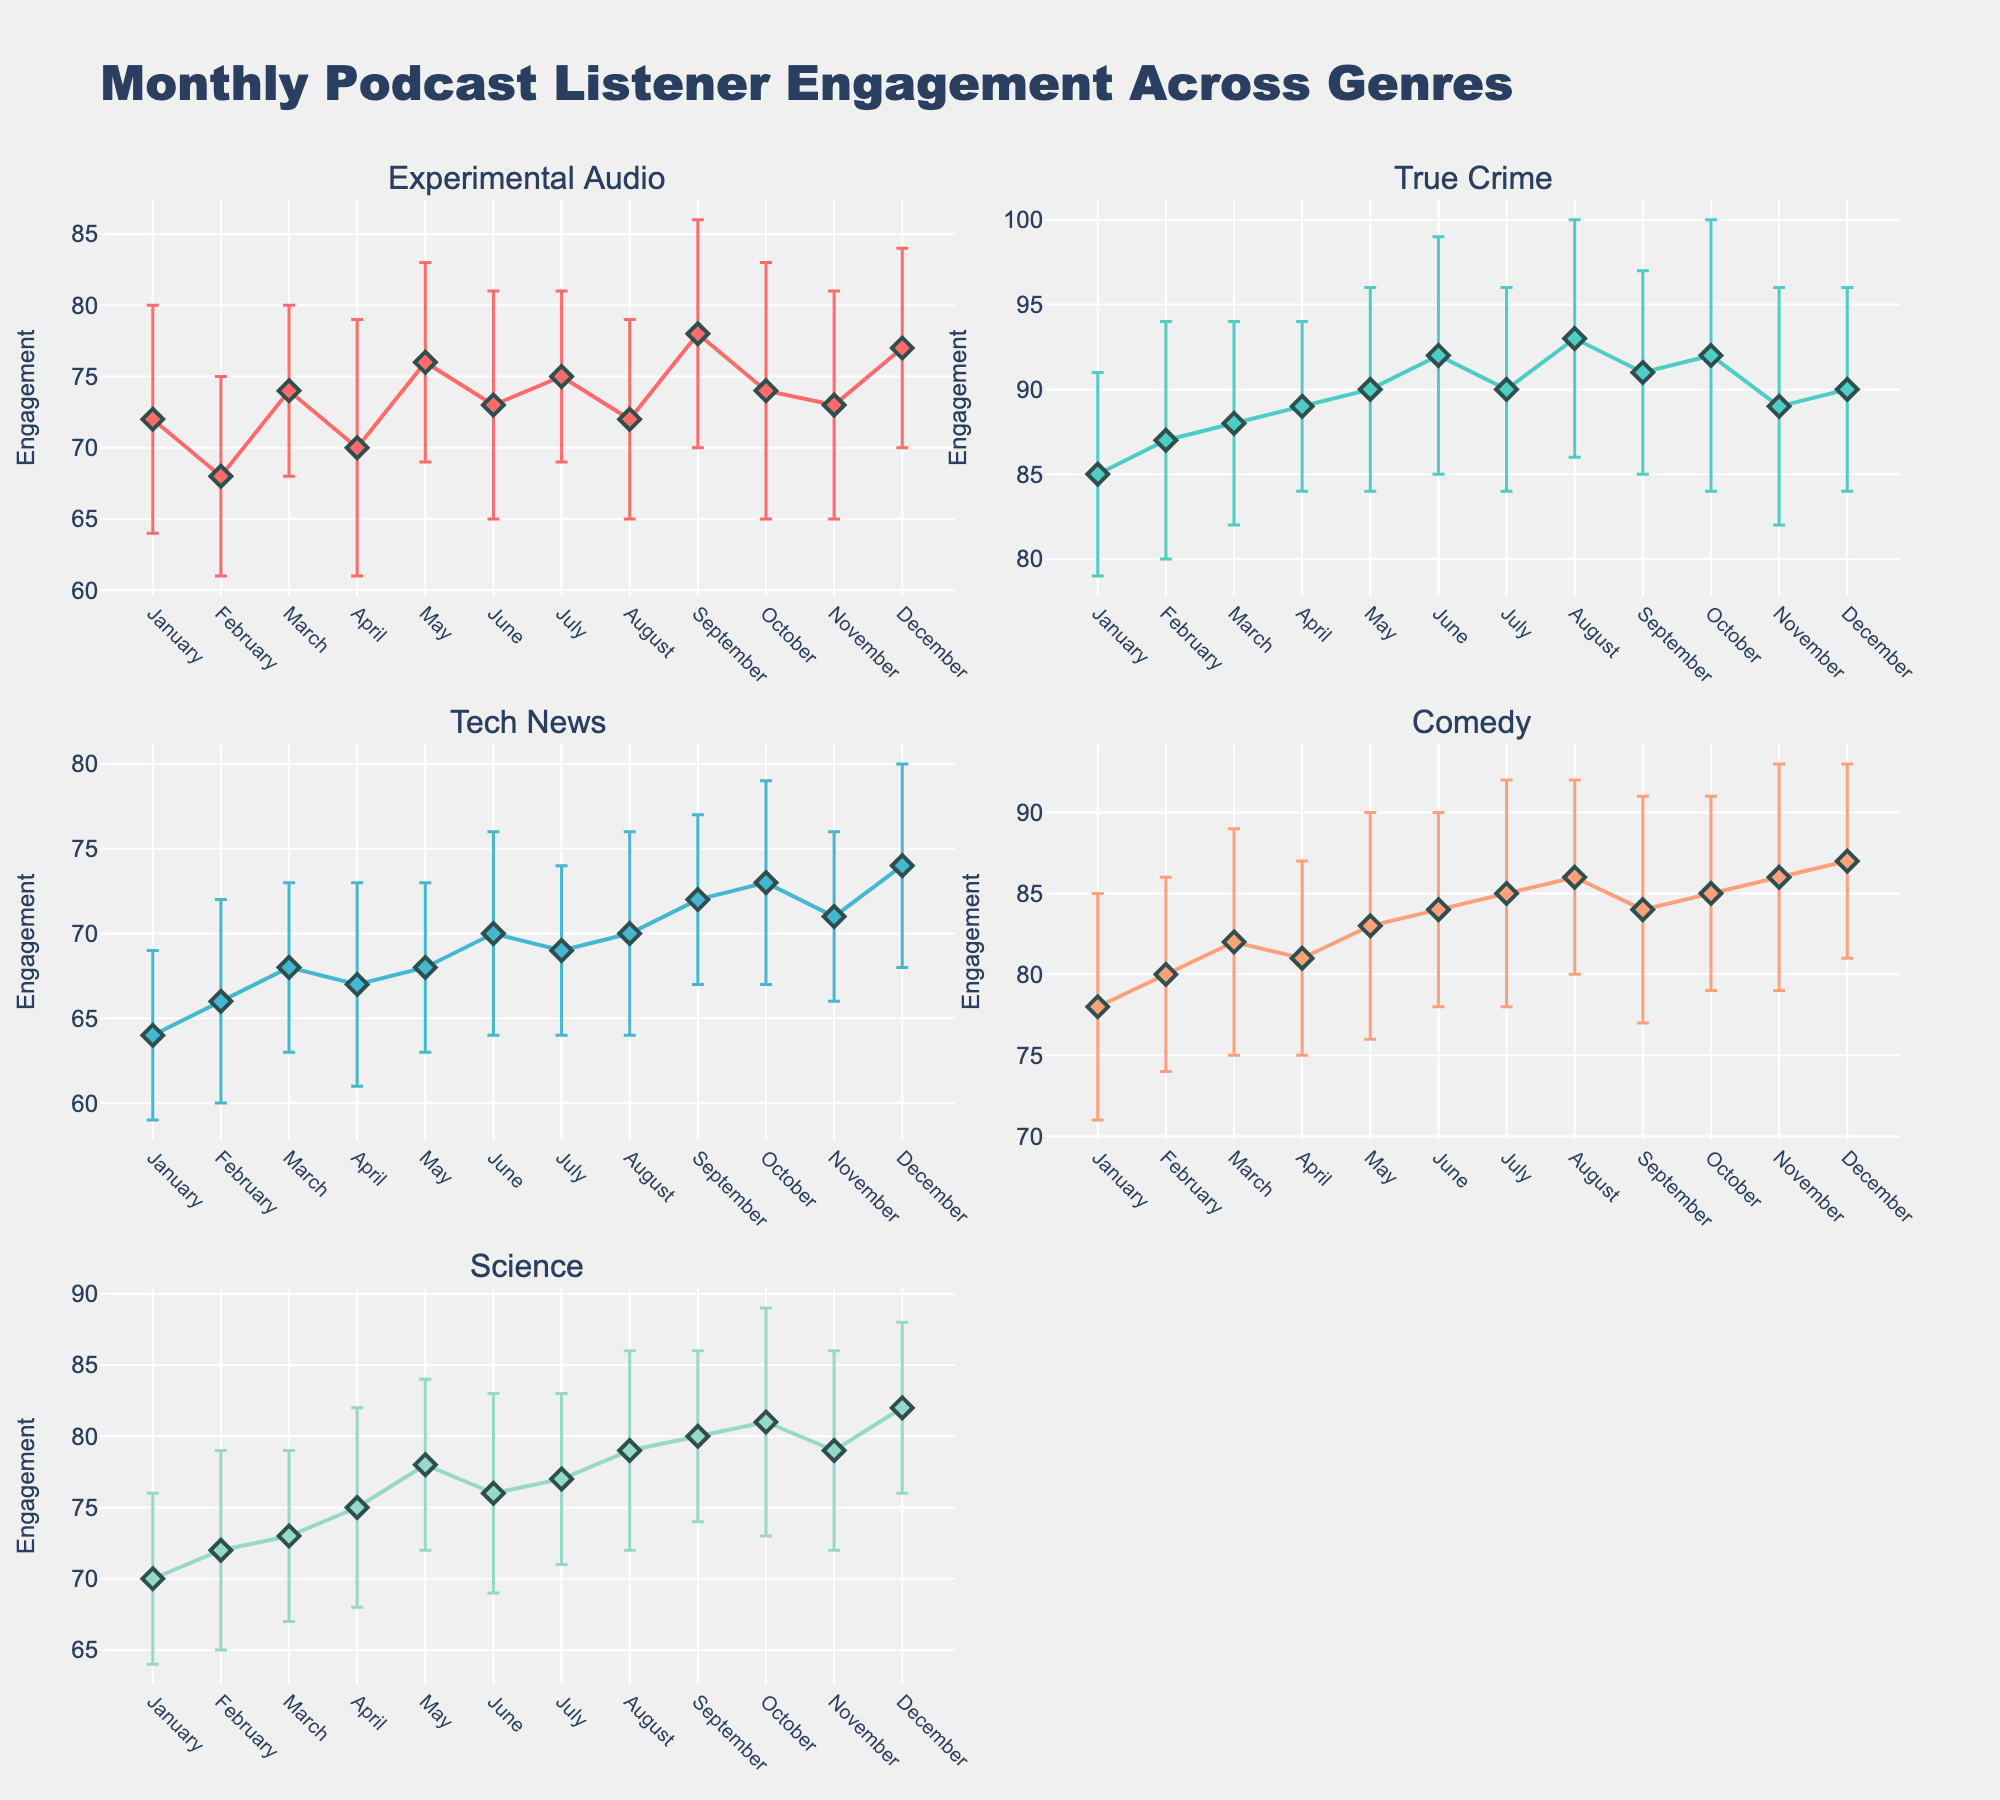What is the title of the plot? The title of the plot is usually positioned at the top of the figure. For this plot, it is "Monthly Podcast Listener Engagement Across Genres".
Answer: Monthly Podcast Listener Engagement Across Genres What does the y-axis represent in these subplots? The y-axis title is indicated for each subplot and is labeled "Engagement". This implies that the y-axis measurements are focused on listener engagement.
Answer: Engagement Which month shows the highest engagement for Experimental Audio? In the subplot for Experimental Audio, the data point for September has the highest mean engagement value, with a mean engagement of 78.
Answer: September Compare the engagement in February for Comedy and Tech News. Which one is higher? By examining each subplot, the engagement for Comedy in February is 80 while that for Tech News is 66. Hence, Comedy has a higher engagement.
Answer: Comedy On average, does Science see an increasing or decreasing trend in engagement from January to December? By looking at the subplot for Science, we can see that each subsequent month generally has a higher engagement than the previous one, signaling an increasing trend.
Answer: Increasing Which genre exhibits the largest fluctuation in engagement over the months, based on the error bars? Fluctuation can be interpreted from the variance represented by the standard deviation error bars. By observing the error bars across genres, Science shows the largest fluctuations with error bars that are generally longer compared to others.
Answer: Science How does the engagement for True Crime in October compare to that in April? From the True Crime subplot, the engagement in October is 92, and in April, it is 89. October's engagement is higher by a value of 3.
Answer: Higher by 3 Which genre has the lowest engagement in January? By examining the January data points in each subplot, the lowest engagement value in January is for Tech News, which has a mean engagement of 64.
Answer: Tech News What is the range of engagement values for Comedy from June to August? The engagement values for Comedy in June, July, and August are 84, 85, and 86 respectively. The range is from 84 to 86.
Answer: 84 to 86 In which month does Experimental Audio have the smallest standard deviation in engagement? Reviewing the error bars (std_dev_engagement values), Experimental Audio has the smallest standard deviation in engagement in March, with a standard deviation of 6.
Answer: March 